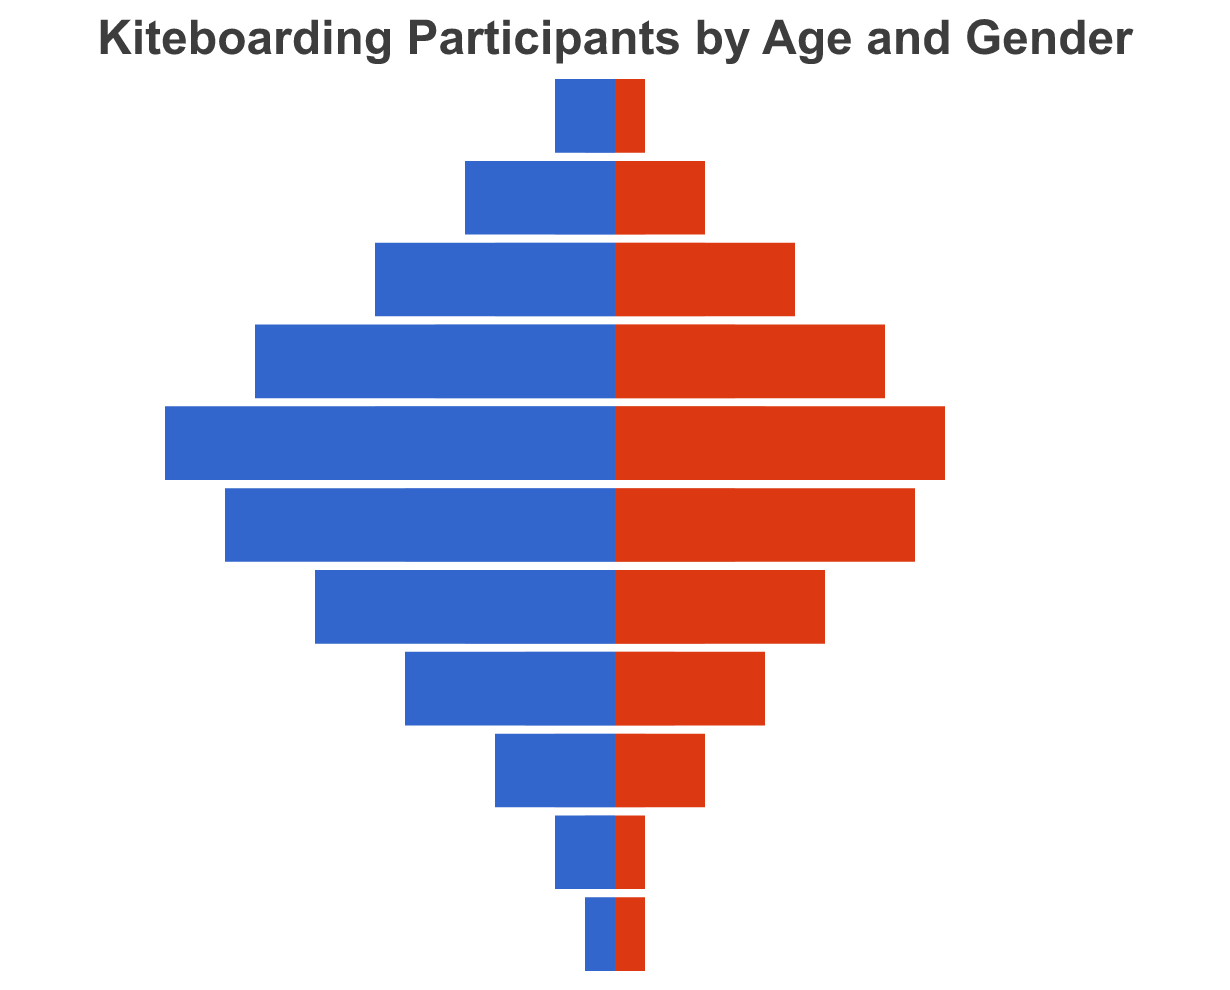What is the title of the figure? The title is generally at the top of a figure and often in bold text. Here, the title would be inside the `title` key in the code.
Answer: Kiteboarding Participants by Age and Gender Which age group has the highest number of male participants in the summer? Look for the maximum value in the "Male Summer" column within the data.
Answer: 30-34 How many male participants are there in the 25-29 age group during the winter? Refer to the data for the "Male Winter" value for the age group "25-29".
Answer: 6 Compare the number of female participants in the 35-39 age group for both summer and winter. Which season has more participants? Look at the "Female Summer" and "Female Winter" values for the 35-39 age group and compare them.
Answer: Summer Calculate the difference between the number of male participants in the summer and winter for the 30-34 age group. Subtract the "Male Winter" value from the "Male Summer" value for the 30-34 age group. So, 15 - 8.
Answer: 7 Between the age groups 40-44 and 45-49, which has more female participants in the summer? Compare the "Female Summer" values of 40-44 and 45-49 age groups.
Answer: 40-44 How many participants are in the 60+ age group in total across all categories? Sum the values of "Male Summer", "Female Summer", "Male Winter", and "Female Winter" for the 60+ age group. So, 1 + 1 + 0 + 0.
Answer: 2 What is the total number of female participants in the 30-34 and 35-39 age groups during the winter? Add the values of "Female Winter" for the 30-34 and 35-39 age groups. So, 5 + 4.
Answer: 9 